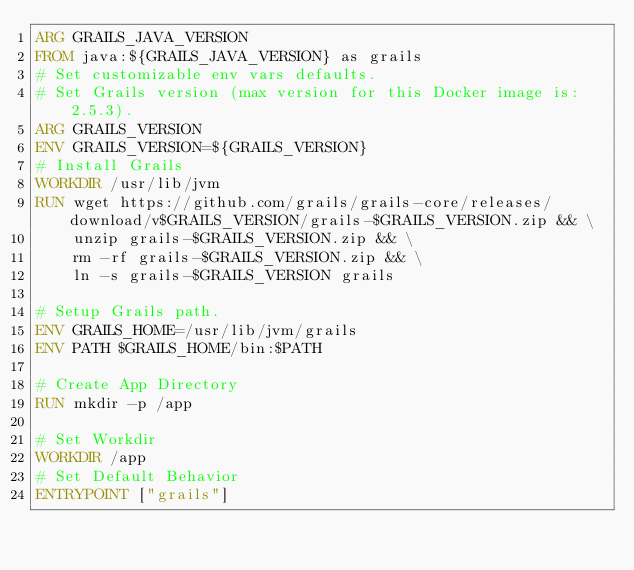<code> <loc_0><loc_0><loc_500><loc_500><_Dockerfile_>ARG GRAILS_JAVA_VERSION
FROM java:${GRAILS_JAVA_VERSION} as grails
# Set customizable env vars defaults.
# Set Grails version (max version for this Docker image is: 2.5.3).
ARG GRAILS_VERSION
ENV GRAILS_VERSION=${GRAILS_VERSION}
# Install Grails
WORKDIR /usr/lib/jvm
RUN wget https://github.com/grails/grails-core/releases/download/v$GRAILS_VERSION/grails-$GRAILS_VERSION.zip && \
    unzip grails-$GRAILS_VERSION.zip && \
    rm -rf grails-$GRAILS_VERSION.zip && \
    ln -s grails-$GRAILS_VERSION grails

# Setup Grails path.
ENV GRAILS_HOME=/usr/lib/jvm/grails
ENV PATH $GRAILS_HOME/bin:$PATH

# Create App Directory
RUN mkdir -p /app

# Set Workdir
WORKDIR /app
# Set Default Behavior
ENTRYPOINT ["grails"]</code> 